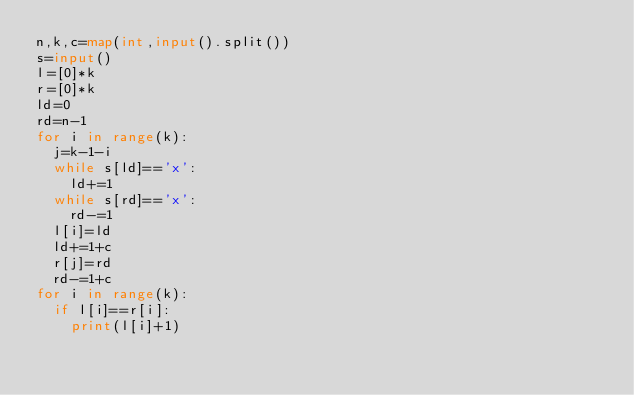<code> <loc_0><loc_0><loc_500><loc_500><_Python_>n,k,c=map(int,input().split())
s=input()
l=[0]*k
r=[0]*k
ld=0
rd=n-1
for i in range(k):
  j=k-1-i
  while s[ld]=='x':
    ld+=1
  while s[rd]=='x':
    rd-=1
  l[i]=ld
  ld+=1+c
  r[j]=rd
  rd-=1+c
for i in range(k):
  if l[i]==r[i]:
    print(l[i]+1)
</code> 